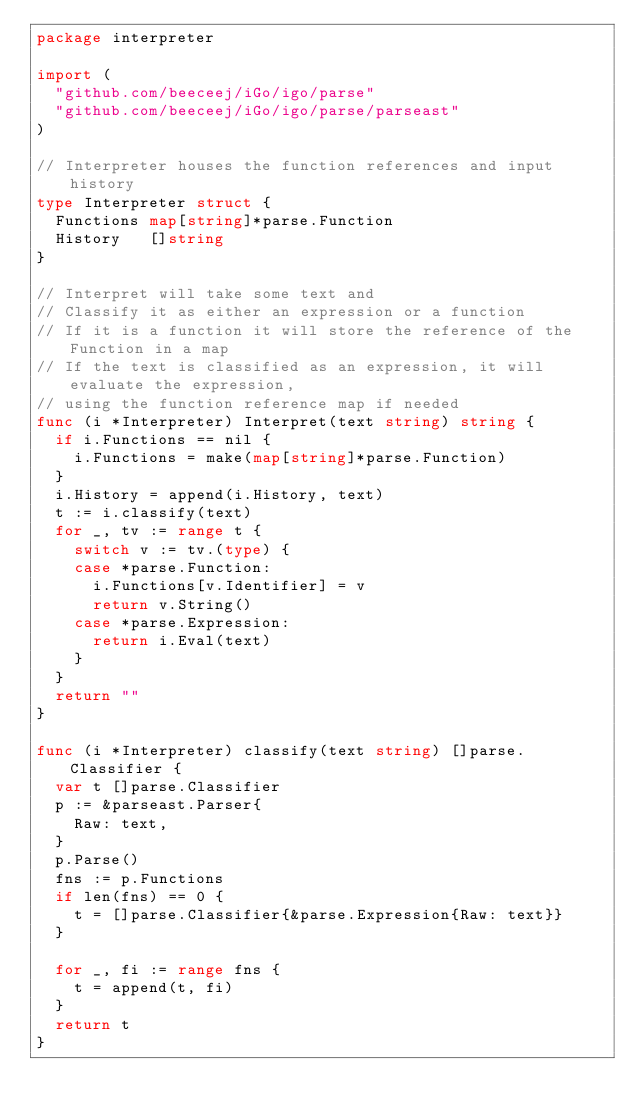<code> <loc_0><loc_0><loc_500><loc_500><_Go_>package interpreter

import (
	"github.com/beeceej/iGo/igo/parse"
	"github.com/beeceej/iGo/igo/parse/parseast"
)

// Interpreter houses the function references and input history
type Interpreter struct {
	Functions map[string]*parse.Function
	History   []string
}

// Interpret will take some text and
// Classify it as either an expression or a function
// If it is a function it will store the reference of the Function in a map
// If the text is classified as an expression, it will evaluate the expression,
// using the function reference map if needed
func (i *Interpreter) Interpret(text string) string {
	if i.Functions == nil {
		i.Functions = make(map[string]*parse.Function)
	}
	i.History = append(i.History, text)
	t := i.classify(text)
	for _, tv := range t {
		switch v := tv.(type) {
		case *parse.Function:
			i.Functions[v.Identifier] = v
			return v.String()
		case *parse.Expression:
			return i.Eval(text)
		}
	}
	return ""
}

func (i *Interpreter) classify(text string) []parse.Classifier {
	var t []parse.Classifier
	p := &parseast.Parser{
		Raw: text,
	}
	p.Parse()
	fns := p.Functions
	if len(fns) == 0 {
		t = []parse.Classifier{&parse.Expression{Raw: text}}
	}

	for _, fi := range fns {
		t = append(t, fi)
	}
	return t
}
</code> 